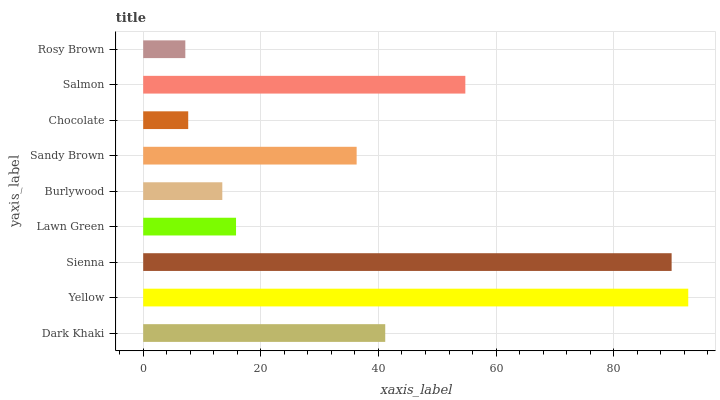Is Rosy Brown the minimum?
Answer yes or no. Yes. Is Yellow the maximum?
Answer yes or no. Yes. Is Sienna the minimum?
Answer yes or no. No. Is Sienna the maximum?
Answer yes or no. No. Is Yellow greater than Sienna?
Answer yes or no. Yes. Is Sienna less than Yellow?
Answer yes or no. Yes. Is Sienna greater than Yellow?
Answer yes or no. No. Is Yellow less than Sienna?
Answer yes or no. No. Is Sandy Brown the high median?
Answer yes or no. Yes. Is Sandy Brown the low median?
Answer yes or no. Yes. Is Lawn Green the high median?
Answer yes or no. No. Is Sienna the low median?
Answer yes or no. No. 